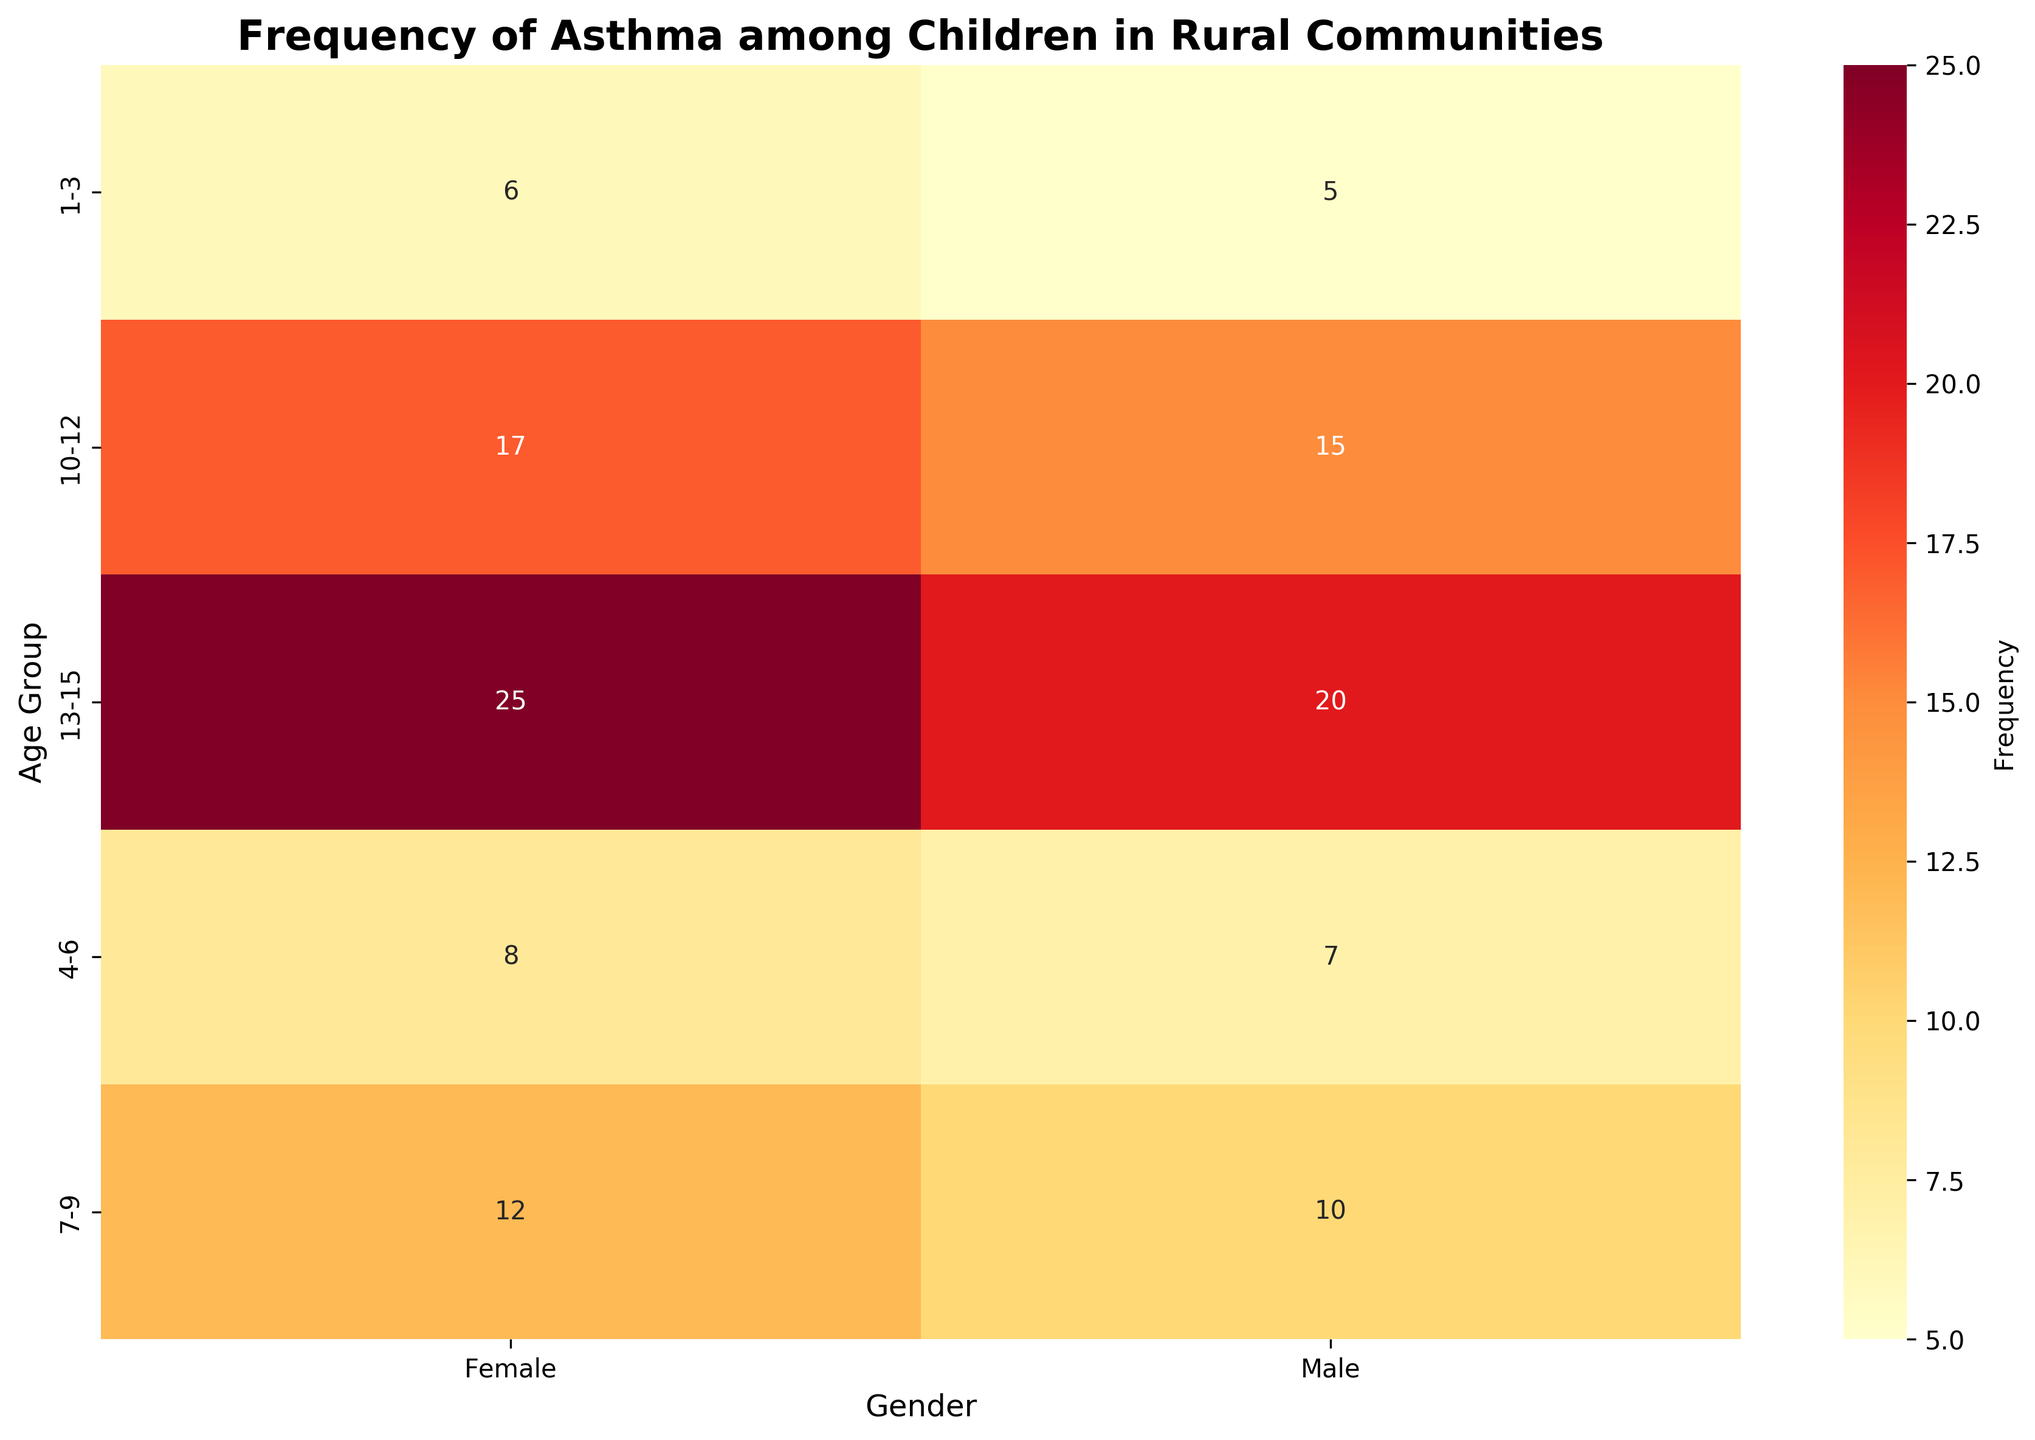What is the title of the heatmap? The title of the heatmap is written at the top of the figure.
Answer: Frequency of Asthma among Children in Rural Communities What do the colors represent in the heatmap? The colors represent the frequency of asthma among children. Darker colors indicate higher frequencies.
Answer: Frequency Which age group and gender have the highest frequency of asthma? Look for the darkest colored cell in the heatmap. The darkest cell indicates the highest frequency.
Answer: 13-15, Female What is the frequency of asthma for males aged 1-3? Locate the cell where the 'Age' is '1-3' and 'Gender' is 'Male', and read the number inside the cell.
Answer: 5 Compare the frequency of asthma between females aged 10-12 and males aged 10-12. Locate the cells where the 'Age' is '10-12' and compare the numbers in the 'Male' and 'Female' columns.
Answer: Females aged 10-12 have a frequency of 17, while males aged 10-12 have a frequency of 15 Sum the frequency of asthma for males in all age groups. Add the numbers in the 'Male' column across all age groups: 5 + 7 + 10 + 15 + 20.
Answer: 57 Which gender generally has a higher frequency of asthma across all age groups? Compare the numbers in the 'Male' and 'Female' columns for each age group and see which column generally has higher numbers.
Answer: Female What is the difference in asthma frequency between females aged 7-9 and females aged 4-6? Subtract the number in the 'Female' column for age group '4-6' from the number in the 'Female' column for age group '7-9'.
Answer: 4 Which age group has the lowest frequency of asthma for both genders? Look for the cells with the smallest numbers in both 'Male' and 'Female' columns, and identify the corresponding age group.
Answer: 1-3 Is the frequency of asthma increasing or decreasing with age for both genders? Observe the trend in the numbers for both 'Male' and 'Female' columns from the youngest to the oldest age groups.
Answer: Increasing 